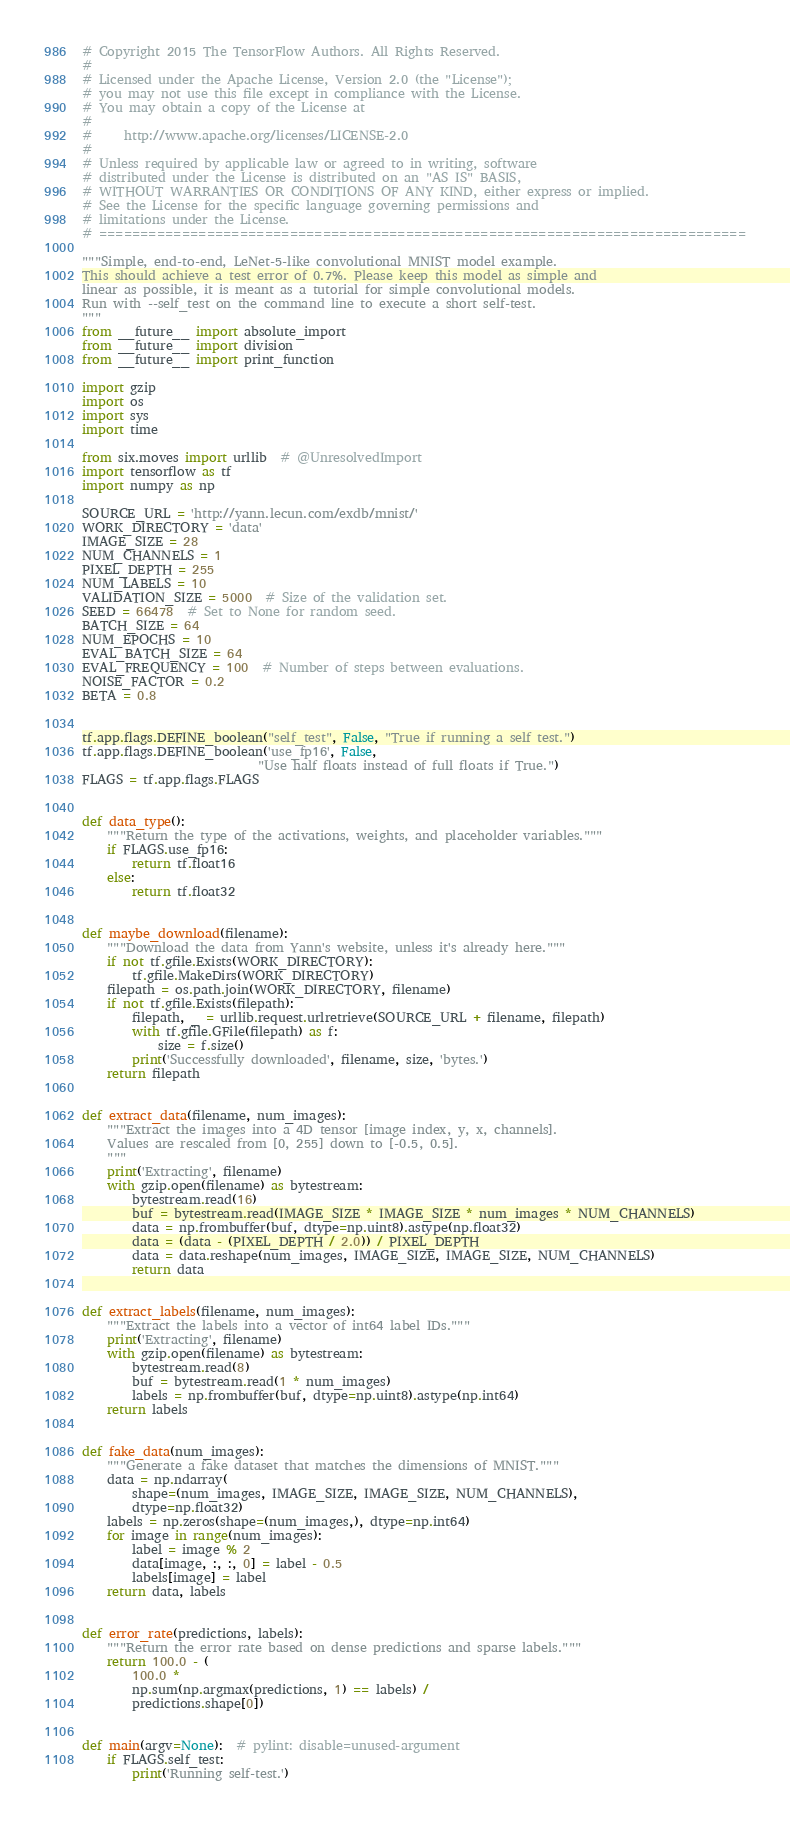<code> <loc_0><loc_0><loc_500><loc_500><_Python_># Copyright 2015 The TensorFlow Authors. All Rights Reserved.
#
# Licensed under the Apache License, Version 2.0 (the "License");
# you may not use this file except in compliance with the License.
# You may obtain a copy of the License at
#
#     http://www.apache.org/licenses/LICENSE-2.0
#
# Unless required by applicable law or agreed to in writing, software
# distributed under the License is distributed on an "AS IS" BASIS,
# WITHOUT WARRANTIES OR CONDITIONS OF ANY KIND, either express or implied.
# See the License for the specific language governing permissions and
# limitations under the License.
# ==============================================================================

"""Simple, end-to-end, LeNet-5-like convolutional MNIST model example.
This should achieve a test error of 0.7%. Please keep this model as simple and
linear as possible, it is meant as a tutorial for simple convolutional models.
Run with --self_test on the command line to execute a short self-test.
"""
from __future__ import absolute_import
from __future__ import division
from __future__ import print_function

import gzip
import os
import sys
import time

from six.moves import urllib  # @UnresolvedImport
import tensorflow as tf
import numpy as np

SOURCE_URL = 'http://yann.lecun.com/exdb/mnist/'
WORK_DIRECTORY = 'data'
IMAGE_SIZE = 28
NUM_CHANNELS = 1
PIXEL_DEPTH = 255
NUM_LABELS = 10
VALIDATION_SIZE = 5000  # Size of the validation set.
SEED = 66478  # Set to None for random seed.
BATCH_SIZE = 64
NUM_EPOCHS = 10
EVAL_BATCH_SIZE = 64
EVAL_FREQUENCY = 100  # Number of steps between evaluations.
NOISE_FACTOR = 0.2
BETA = 0.8


tf.app.flags.DEFINE_boolean("self_test", False, "True if running a self test.")
tf.app.flags.DEFINE_boolean('use_fp16', False,
                            "Use half floats instead of full floats if True.")
FLAGS = tf.app.flags.FLAGS


def data_type():
    """Return the type of the activations, weights, and placeholder variables."""
    if FLAGS.use_fp16:
        return tf.float16
    else:
        return tf.float32


def maybe_download(filename):
    """Download the data from Yann's website, unless it's already here."""
    if not tf.gfile.Exists(WORK_DIRECTORY):
        tf.gfile.MakeDirs(WORK_DIRECTORY)
    filepath = os.path.join(WORK_DIRECTORY, filename)
    if not tf.gfile.Exists(filepath):
        filepath, _ = urllib.request.urlretrieve(SOURCE_URL + filename, filepath)
        with tf.gfile.GFile(filepath) as f:
            size = f.size()
        print('Successfully downloaded', filename, size, 'bytes.')
    return filepath


def extract_data(filename, num_images):
    """Extract the images into a 4D tensor [image index, y, x, channels].
    Values are rescaled from [0, 255] down to [-0.5, 0.5].
    """
    print('Extracting', filename)
    with gzip.open(filename) as bytestream:
        bytestream.read(16)
        buf = bytestream.read(IMAGE_SIZE * IMAGE_SIZE * num_images * NUM_CHANNELS)
        data = np.frombuffer(buf, dtype=np.uint8).astype(np.float32)
        data = (data - (PIXEL_DEPTH / 2.0)) / PIXEL_DEPTH
        data = data.reshape(num_images, IMAGE_SIZE, IMAGE_SIZE, NUM_CHANNELS)
        return data


def extract_labels(filename, num_images):
    """Extract the labels into a vector of int64 label IDs."""
    print('Extracting', filename)
    with gzip.open(filename) as bytestream:
        bytestream.read(8)
        buf = bytestream.read(1 * num_images)
        labels = np.frombuffer(buf, dtype=np.uint8).astype(np.int64)
    return labels


def fake_data(num_images):
    """Generate a fake dataset that matches the dimensions of MNIST."""
    data = np.ndarray(
        shape=(num_images, IMAGE_SIZE, IMAGE_SIZE, NUM_CHANNELS),
        dtype=np.float32)
    labels = np.zeros(shape=(num_images,), dtype=np.int64)
    for image in range(num_images):
        label = image % 2
        data[image, :, :, 0] = label - 0.5
        labels[image] = label
    return data, labels


def error_rate(predictions, labels):
    """Return the error rate based on dense predictions and sparse labels."""
    return 100.0 - (
        100.0 *
        np.sum(np.argmax(predictions, 1) == labels) /
        predictions.shape[0])


def main(argv=None):  # pylint: disable=unused-argument
    if FLAGS.self_test:
        print('Running self-test.')</code> 